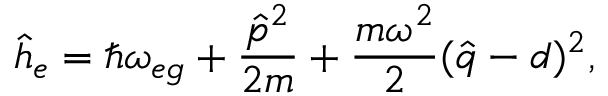<formula> <loc_0><loc_0><loc_500><loc_500>\hat { h } _ { e } = \hbar { \omega } _ { e g } + \frac { \hat { p } ^ { 2 } } { 2 m } + \frac { m \omega ^ { 2 } } { 2 } ( \hat { q } - d ) ^ { 2 } ,</formula> 